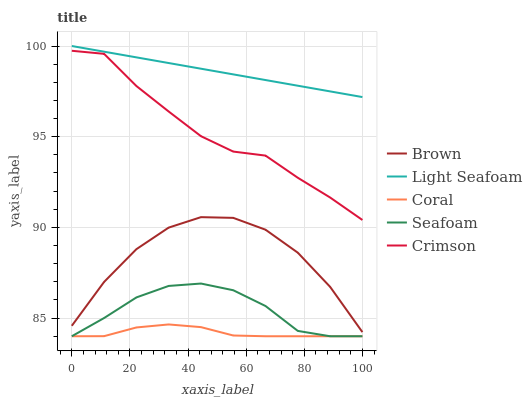Does Coral have the minimum area under the curve?
Answer yes or no. Yes. Does Light Seafoam have the maximum area under the curve?
Answer yes or no. Yes. Does Brown have the minimum area under the curve?
Answer yes or no. No. Does Brown have the maximum area under the curve?
Answer yes or no. No. Is Light Seafoam the smoothest?
Answer yes or no. Yes. Is Brown the roughest?
Answer yes or no. Yes. Is Coral the smoothest?
Answer yes or no. No. Is Coral the roughest?
Answer yes or no. No. Does Brown have the lowest value?
Answer yes or no. No. Does Light Seafoam have the highest value?
Answer yes or no. Yes. Does Brown have the highest value?
Answer yes or no. No. Is Seafoam less than Crimson?
Answer yes or no. Yes. Is Crimson greater than Brown?
Answer yes or no. Yes. Does Seafoam intersect Coral?
Answer yes or no. Yes. Is Seafoam less than Coral?
Answer yes or no. No. Is Seafoam greater than Coral?
Answer yes or no. No. Does Seafoam intersect Crimson?
Answer yes or no. No. 